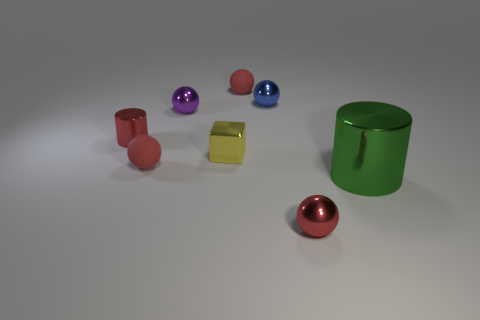Are there any other things that are the same size as the green metal object?
Your answer should be compact. No. The large thing is what color?
Offer a very short reply. Green. What number of tiny yellow things have the same shape as the blue object?
Keep it short and to the point. 0. What color is the metallic cylinder that is the same size as the yellow metal thing?
Offer a terse response. Red. Are any red objects visible?
Provide a succinct answer. Yes. What is the shape of the small red metallic thing right of the purple ball?
Provide a succinct answer. Sphere. What number of shiny things are both left of the small block and behind the red metallic cylinder?
Ensure brevity in your answer.  1. Is there a big purple ball made of the same material as the yellow cube?
Offer a very short reply. No. How many cubes are tiny yellow objects or small purple metallic objects?
Your answer should be very brief. 1. What size is the yellow thing?
Provide a succinct answer. Small. 